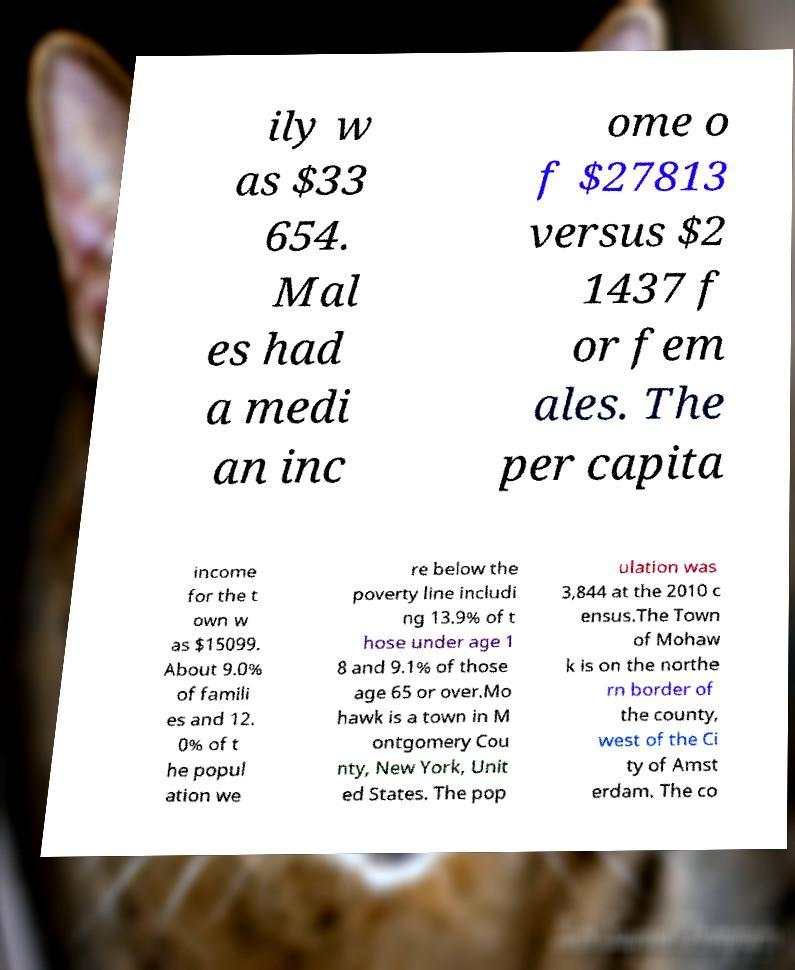What messages or text are displayed in this image? I need them in a readable, typed format. ily w as $33 654. Mal es had a medi an inc ome o f $27813 versus $2 1437 f or fem ales. The per capita income for the t own w as $15099. About 9.0% of famili es and 12. 0% of t he popul ation we re below the poverty line includi ng 13.9% of t hose under age 1 8 and 9.1% of those age 65 or over.Mo hawk is a town in M ontgomery Cou nty, New York, Unit ed States. The pop ulation was 3,844 at the 2010 c ensus.The Town of Mohaw k is on the northe rn border of the county, west of the Ci ty of Amst erdam. The co 